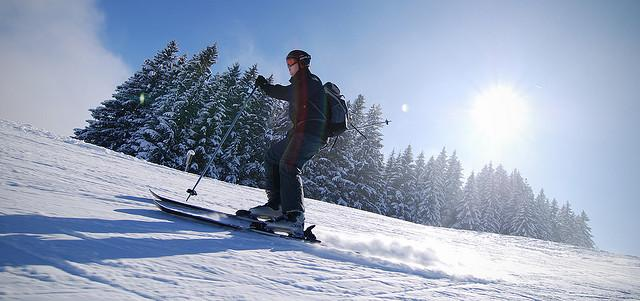What does the giant ball do? provide sunlight 